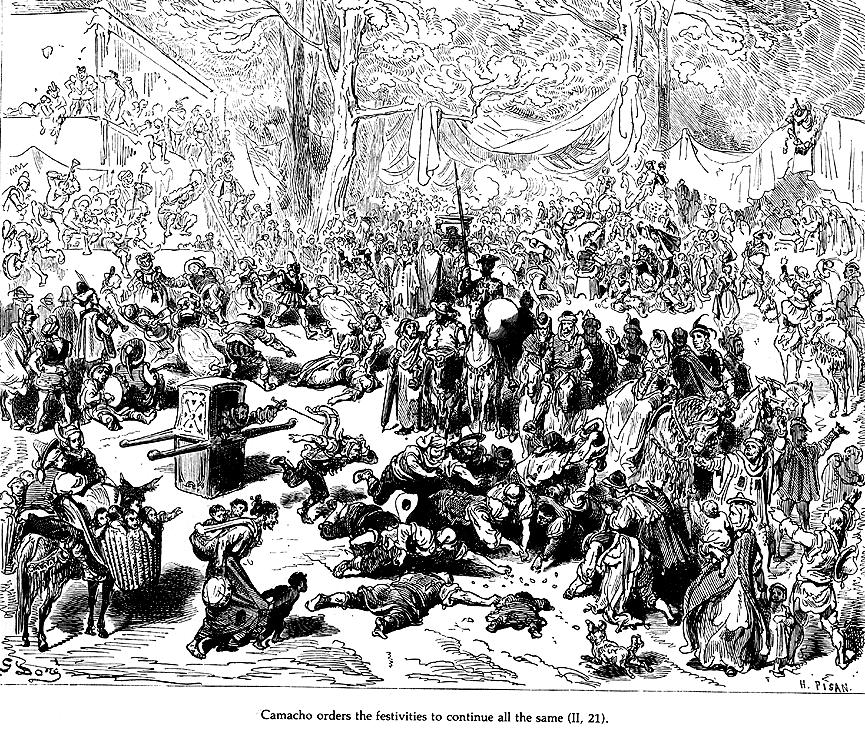Can you explain the significance of the central figure in this illustration? The central figure in this image is Camacho, a wealthy character from 'Don Quixote'. His prominence in the scene underscores his social and economic clout within this rural community. Camacho, dressed distinctively and situated higher than others, symbolizes authority and the economic disparity evident in the celebration. His role is pivotal, as his decisions influence the ongoing festivities and the crowd's response, effectively highlighting themes of leadership and influence in the narrative. 